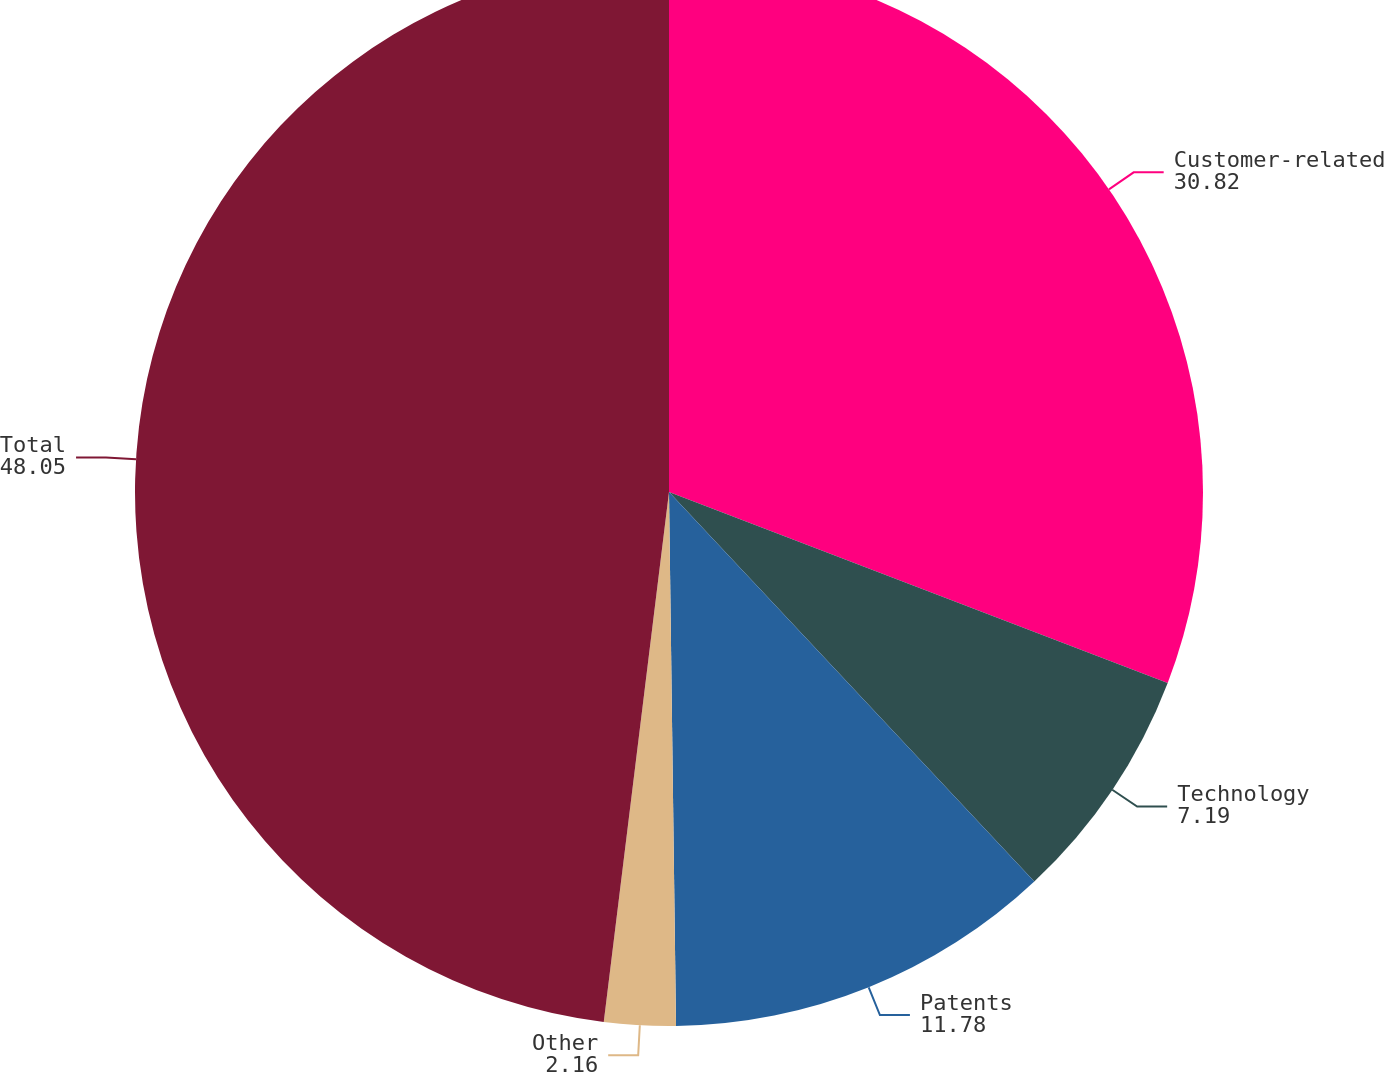Convert chart to OTSL. <chart><loc_0><loc_0><loc_500><loc_500><pie_chart><fcel>Customer-related<fcel>Technology<fcel>Patents<fcel>Other<fcel>Total<nl><fcel>30.82%<fcel>7.19%<fcel>11.78%<fcel>2.16%<fcel>48.05%<nl></chart> 